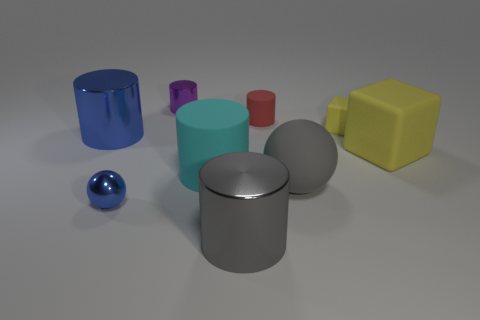Subtract all green cylinders. Subtract all red blocks. How many cylinders are left? 5 Add 1 tiny gray cylinders. How many objects exist? 10 Subtract all balls. How many objects are left? 7 Add 4 blue cylinders. How many blue cylinders exist? 5 Subtract 1 gray balls. How many objects are left? 8 Subtract all small matte blocks. Subtract all small purple metallic objects. How many objects are left? 7 Add 5 tiny red things. How many tiny red things are left? 6 